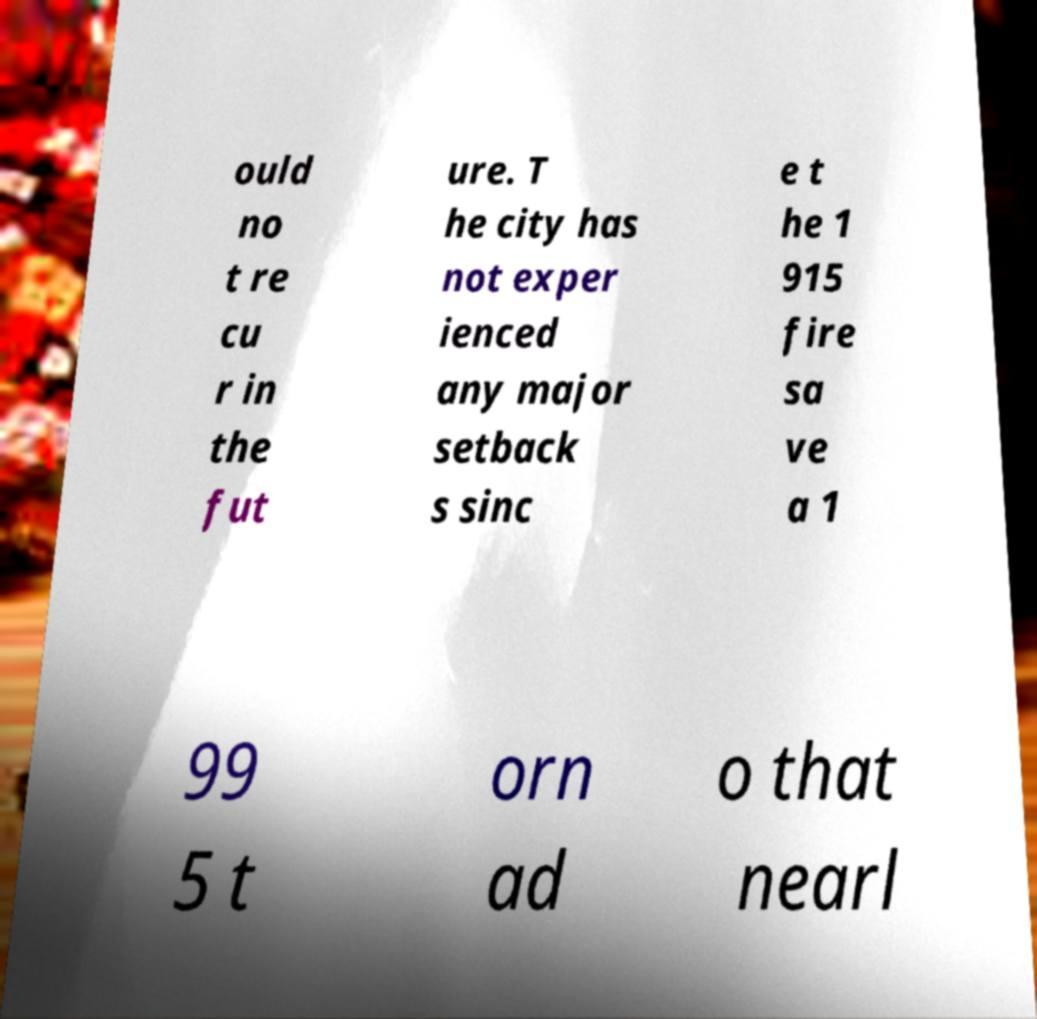There's text embedded in this image that I need extracted. Can you transcribe it verbatim? ould no t re cu r in the fut ure. T he city has not exper ienced any major setback s sinc e t he 1 915 fire sa ve a 1 99 5 t orn ad o that nearl 